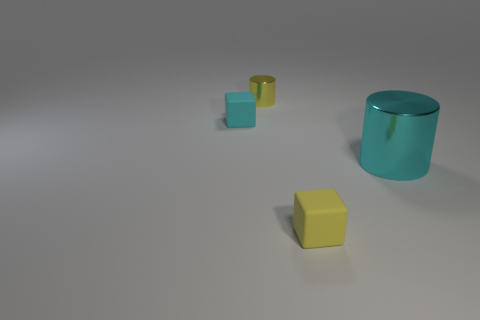Add 2 big gray metal things. How many objects exist? 6 Add 4 yellow metal cylinders. How many yellow metal cylinders are left? 5 Add 2 tiny yellow metal cylinders. How many tiny yellow metal cylinders exist? 3 Subtract 0 blue balls. How many objects are left? 4 Subtract all blocks. Subtract all small cyan rubber blocks. How many objects are left? 1 